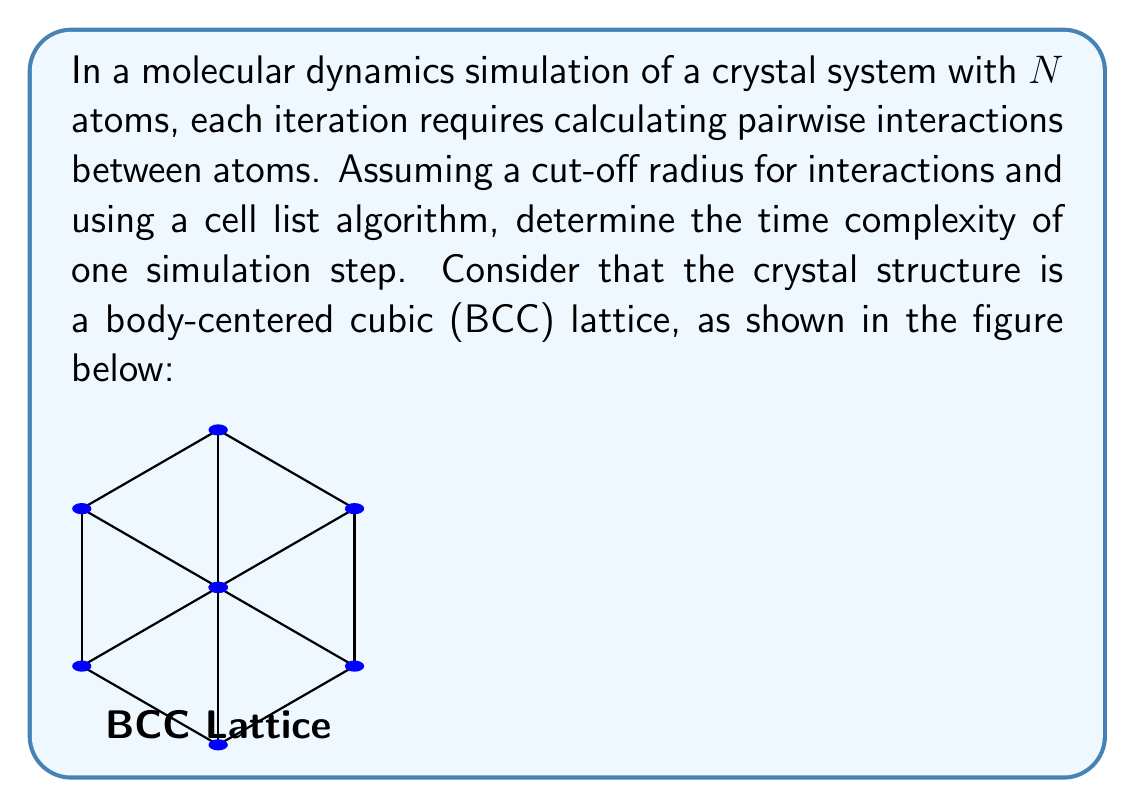Can you answer this question? To determine the time complexity of one simulation step in a molecular dynamics simulation of a BCC crystal system, we need to consider the following steps:

1) In a BCC lattice, each unit cell contains 2 atoms (1 at the center and 1/8 of each of the 8 corner atoms).

2) The cell list algorithm divides the simulation box into smaller cells, each with a side length equal to or greater than the cut-off radius.

3) For each atom, we only need to check interactions with atoms in the same cell and neighboring cells.

4) The number of cells is proportional to $N$, and the number of atoms per cell is constant (independent of $N$).

5) For each atom, we perform a constant number of operations (checking neighboring cells and calculating interactions within the cut-off radius).

Let's analyze the time complexity:

- Constructing the cell list: $O(N)$
- For each of the $N$ atoms:
  - Checking neighboring cells: $O(1)$
  - Calculating interactions with atoms in these cells: $O(1)$

Therefore, the total time complexity for one simulation step is:

$$O(N) + N \cdot O(1) = O(N)$$

This linear time complexity $O(N)$ is achieved because the cell list algorithm effectively reduces the number of pairwise interactions that need to be computed for each atom to a constant, regardless of the total system size.
Answer: $O(N)$ 